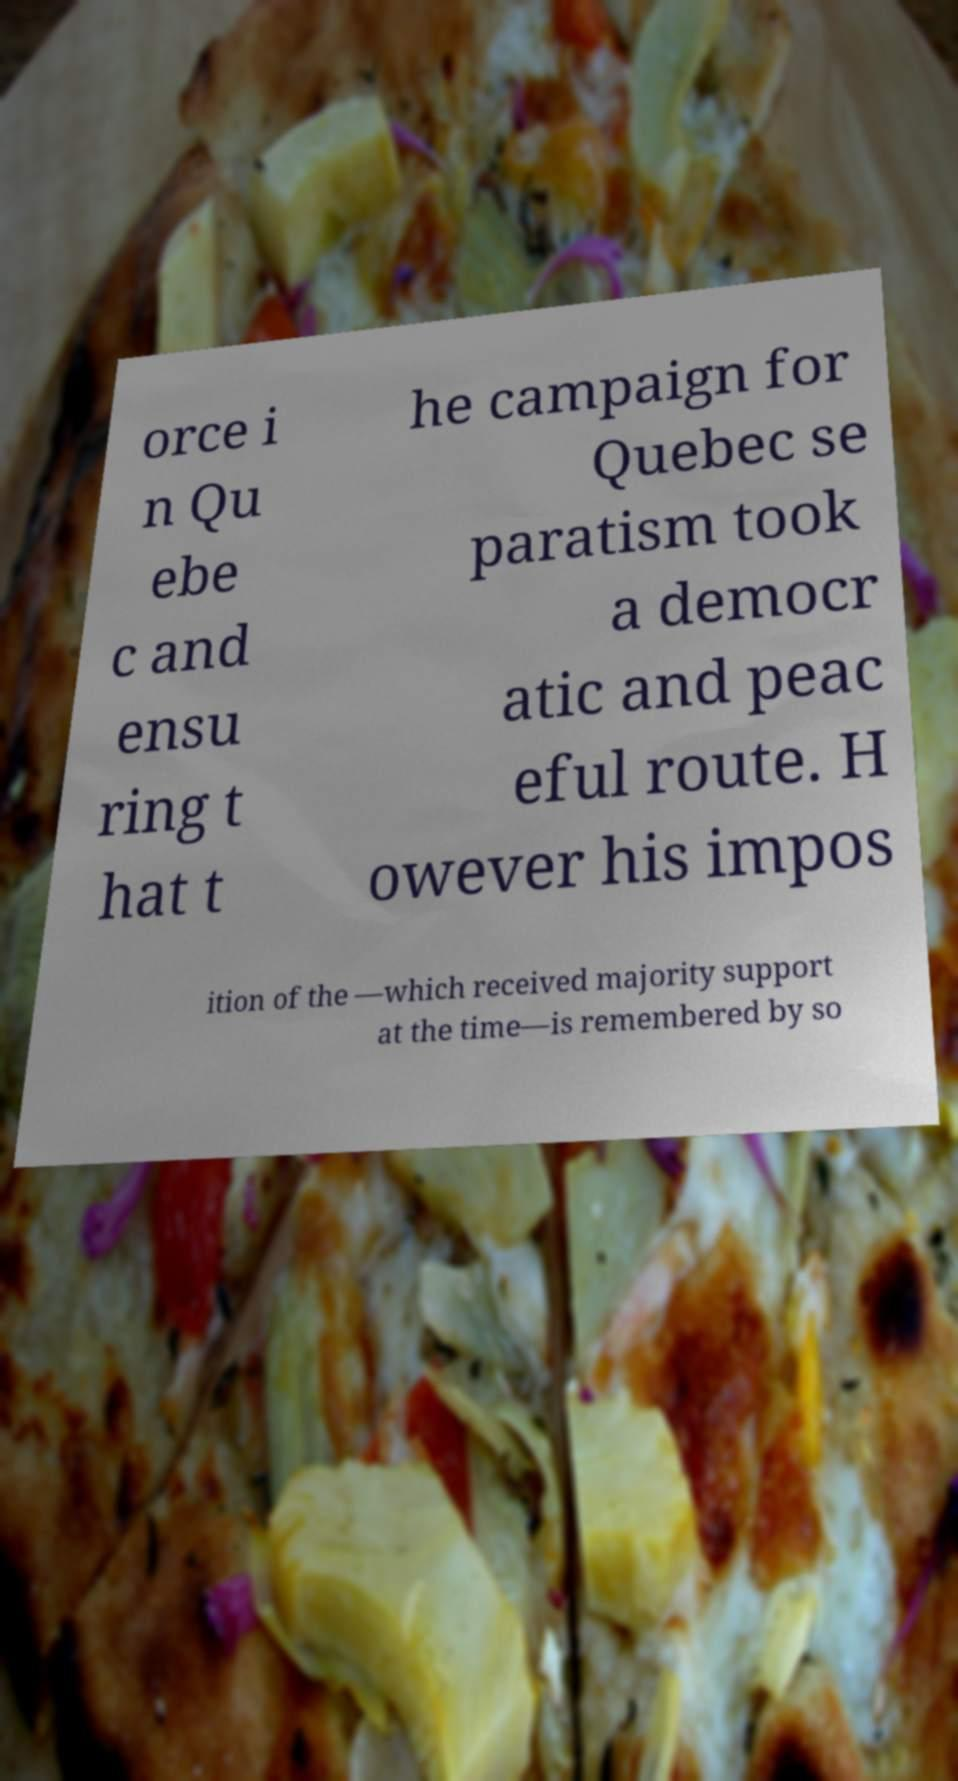Can you read and provide the text displayed in the image?This photo seems to have some interesting text. Can you extract and type it out for me? orce i n Qu ebe c and ensu ring t hat t he campaign for Quebec se paratism took a democr atic and peac eful route. H owever his impos ition of the —which received majority support at the time—is remembered by so 